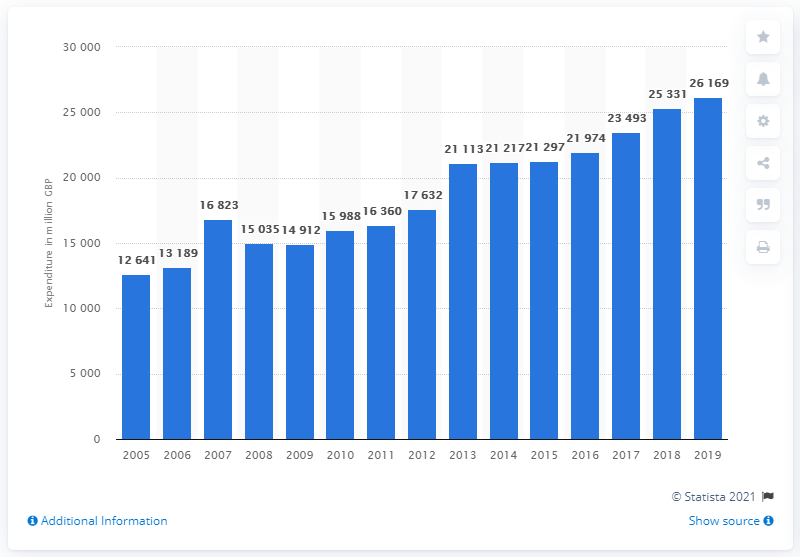Give some essential details in this illustration. In 2019, the value of health products and services purchased by households in the UK was approximately 26,169. 